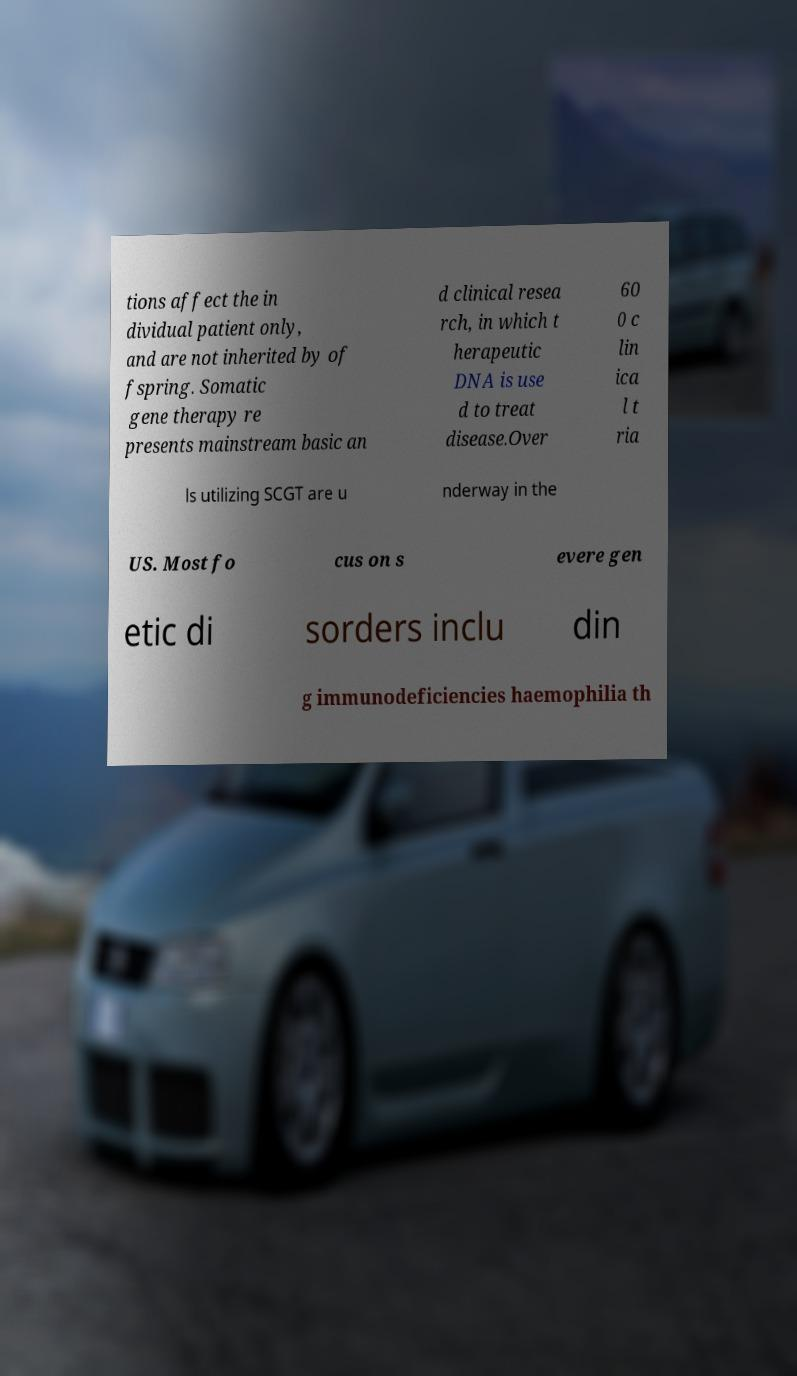Please read and relay the text visible in this image. What does it say? tions affect the in dividual patient only, and are not inherited by of fspring. Somatic gene therapy re presents mainstream basic an d clinical resea rch, in which t herapeutic DNA is use d to treat disease.Over 60 0 c lin ica l t ria ls utilizing SCGT are u nderway in the US. Most fo cus on s evere gen etic di sorders inclu din g immunodeficiencies haemophilia th 